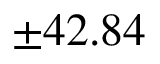<formula> <loc_0><loc_0><loc_500><loc_500>\pm 4 2 . 8 4 \</formula> 